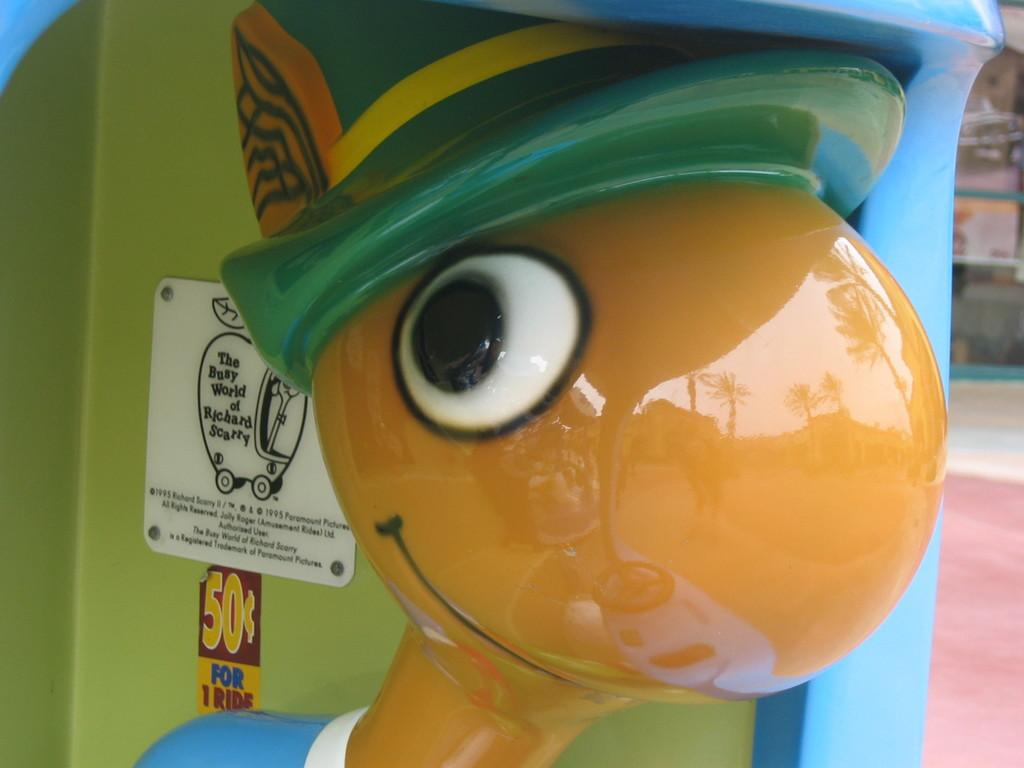What object can be seen in the image? There is a toy in the image. What is located behind the toy? There is a sticker and a board behind the toy. Can you describe any additional details about the toy? There are screws visible in the image, and the toy reflects the trees and the sky. How many pets are visible in the image? There are no pets visible in the image. What type of clam is being used as a toy in the image? There is no clam present in the image; it features a toy that does not resemble a clam. 